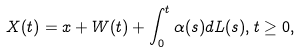Convert formula to latex. <formula><loc_0><loc_0><loc_500><loc_500>X ( t ) = x + W ( t ) + \int _ { 0 } ^ { t } \alpha ( s ) d L ( s ) , t \geq 0 ,</formula> 